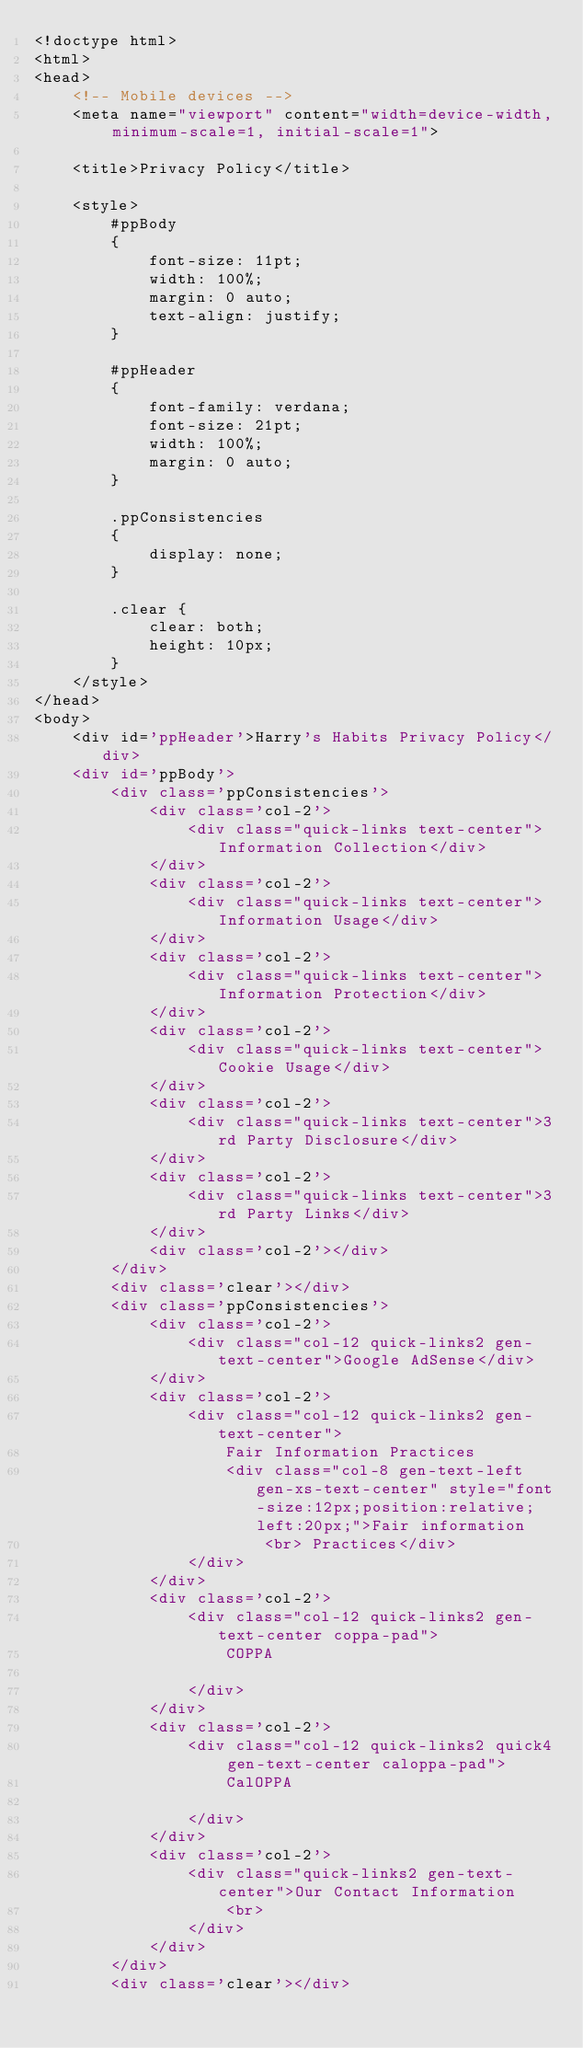Convert code to text. <code><loc_0><loc_0><loc_500><loc_500><_HTML_><!doctype html>
<html>
<head>
    <!-- Mobile devices -->
    <meta name="viewport" content="width=device-width, minimum-scale=1, initial-scale=1">

    <title>Privacy Policy</title>

    <style>
        #ppBody
        {
            font-size: 11pt;
            width: 100%;
            margin: 0 auto;
            text-align: justify;
        }

        #ppHeader
        {
            font-family: verdana;
            font-size: 21pt;
            width: 100%;
            margin: 0 auto;
        }

        .ppConsistencies
        {
            display: none;
        }

        .clear {
            clear: both;
            height: 10px;
        }
    </style>
</head>
<body>
    <div id='ppHeader'>Harry's Habits Privacy Policy</div>
    <div id='ppBody'>
        <div class='ppConsistencies'>
            <div class='col-2'>
                <div class="quick-links text-center">Information Collection</div>
            </div>
            <div class='col-2'>
                <div class="quick-links text-center">Information Usage</div>
            </div>
            <div class='col-2'>
                <div class="quick-links text-center">Information Protection</div>
            </div>
            <div class='col-2'>
                <div class="quick-links text-center">Cookie Usage</div>
            </div>
            <div class='col-2'>
                <div class="quick-links text-center">3rd Party Disclosure</div>
            </div>
            <div class='col-2'>
                <div class="quick-links text-center">3rd Party Links</div>
            </div>
            <div class='col-2'></div>
        </div>
        <div class='clear'></div>
        <div class='ppConsistencies'>
            <div class='col-2'>
                <div class="col-12 quick-links2 gen-text-center">Google AdSense</div>
            </div>
            <div class='col-2'>
                <div class="col-12 quick-links2 gen-text-center">
                    Fair Information Practices
                    <div class="col-8 gen-text-left gen-xs-text-center" style="font-size:12px;position:relative;left:20px;">Fair information
                        <br> Practices</div>
                </div>
            </div>
            <div class='col-2'>
                <div class="col-12 quick-links2 gen-text-center coppa-pad">
                    COPPA

                </div>
            </div>
            <div class='col-2'>
                <div class="col-12 quick-links2 quick4 gen-text-center caloppa-pad">
                    CalOPPA

                </div>
            </div>
            <div class='col-2'>
                <div class="quick-links2 gen-text-center">Our Contact Information
                    <br>
                </div>
            </div>
        </div>
        <div class='clear'></div></code> 